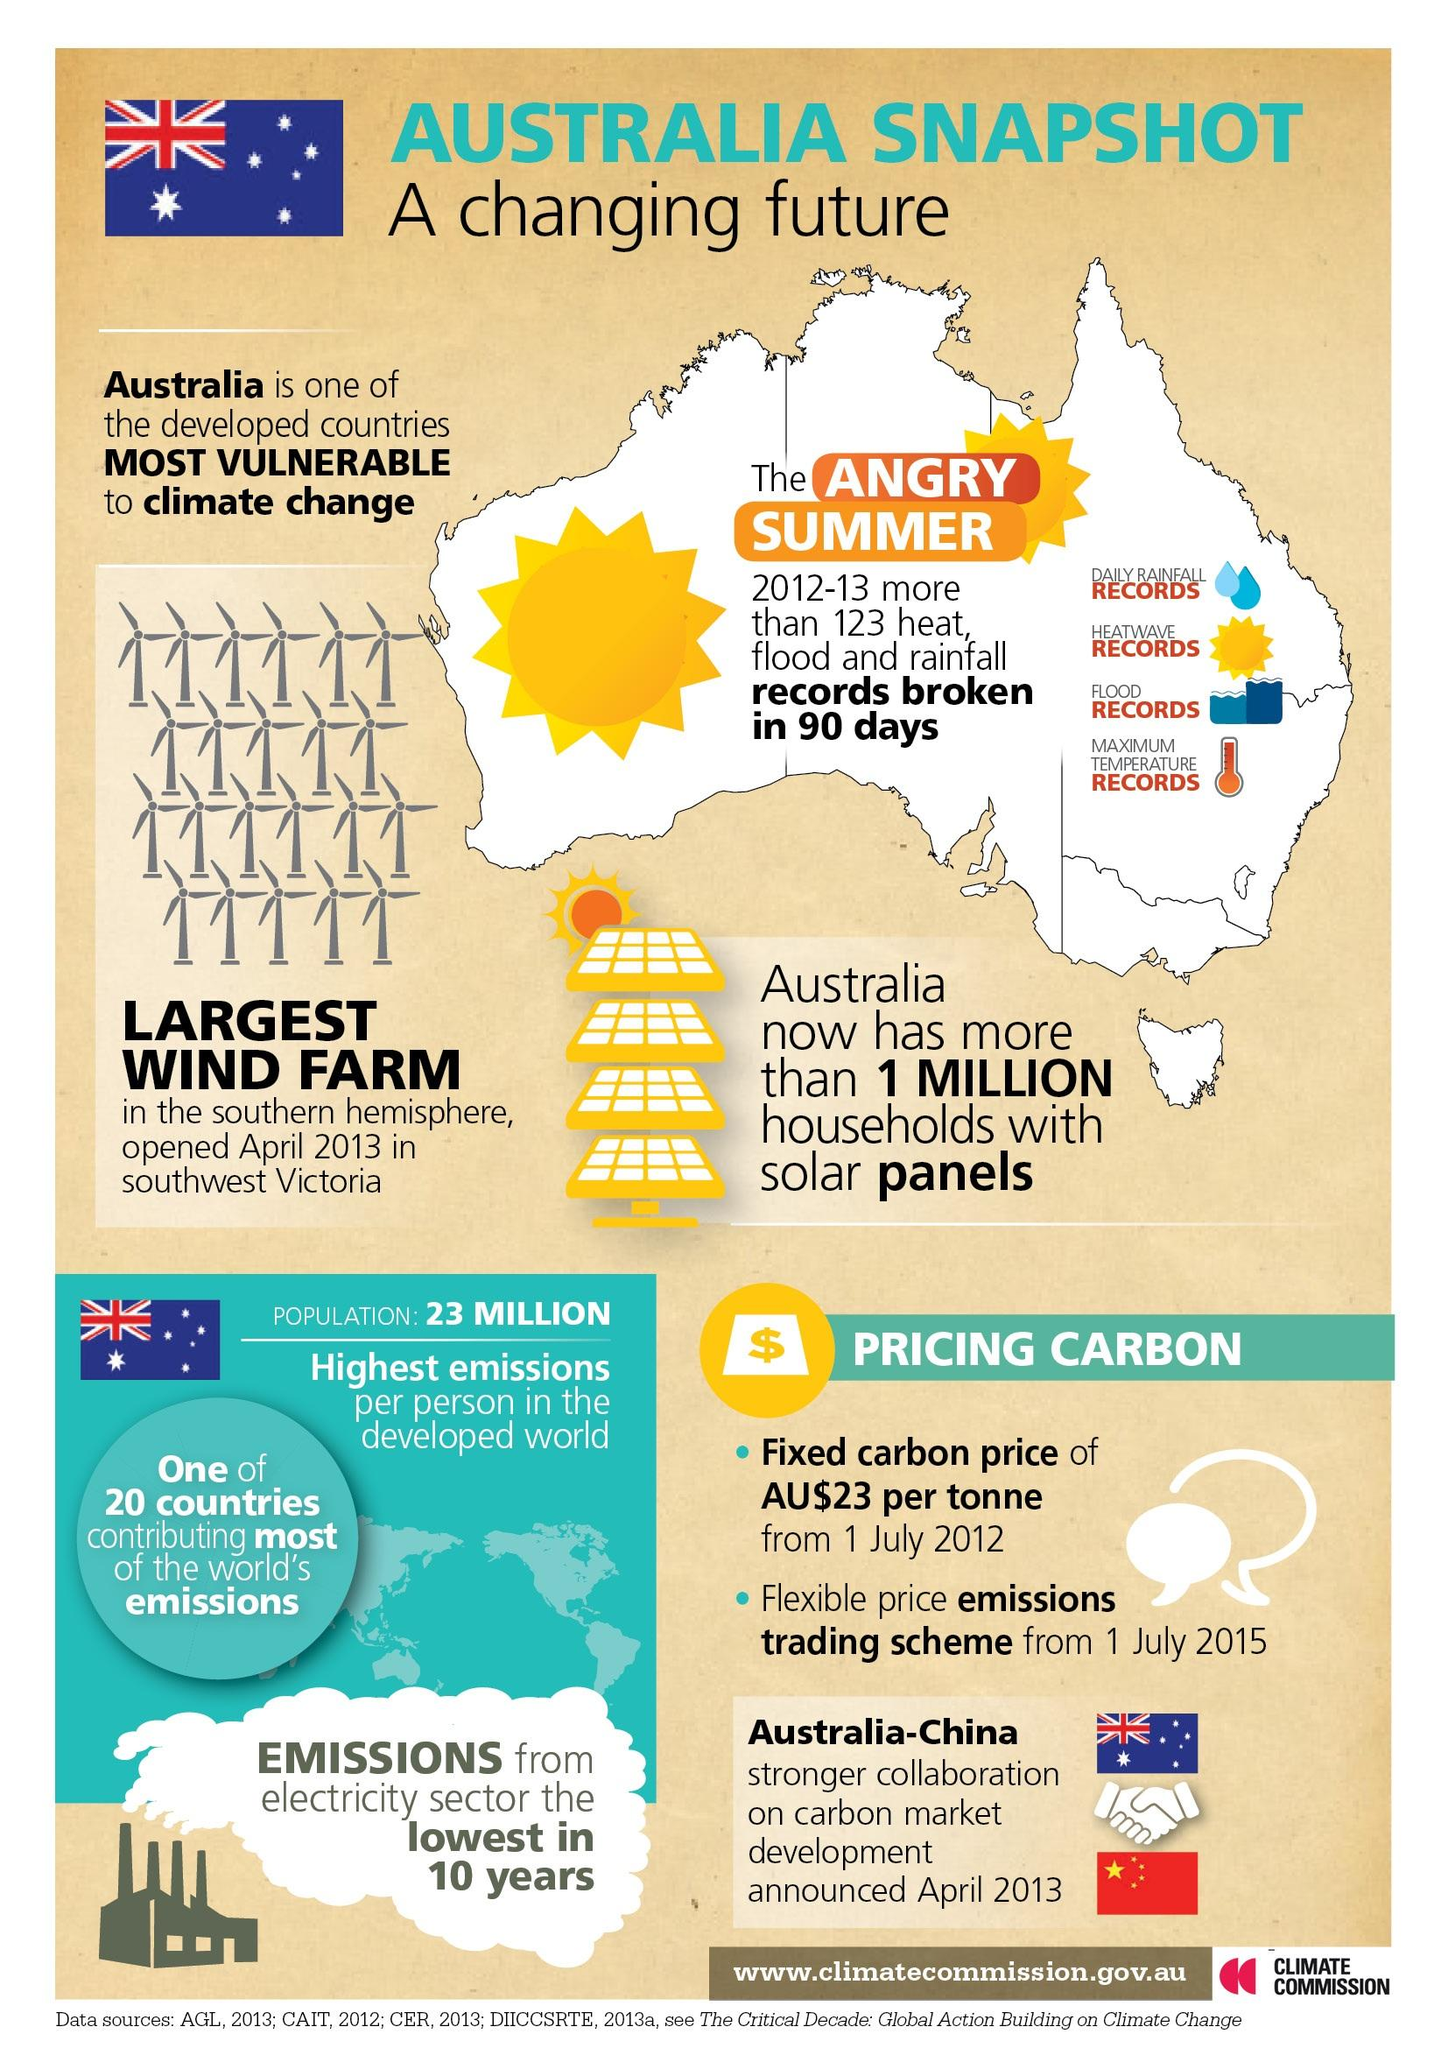Identify some key points in this picture. The symbol of the Australian dollar is AU$. The largest wind farm is located in southwest Victoria. 